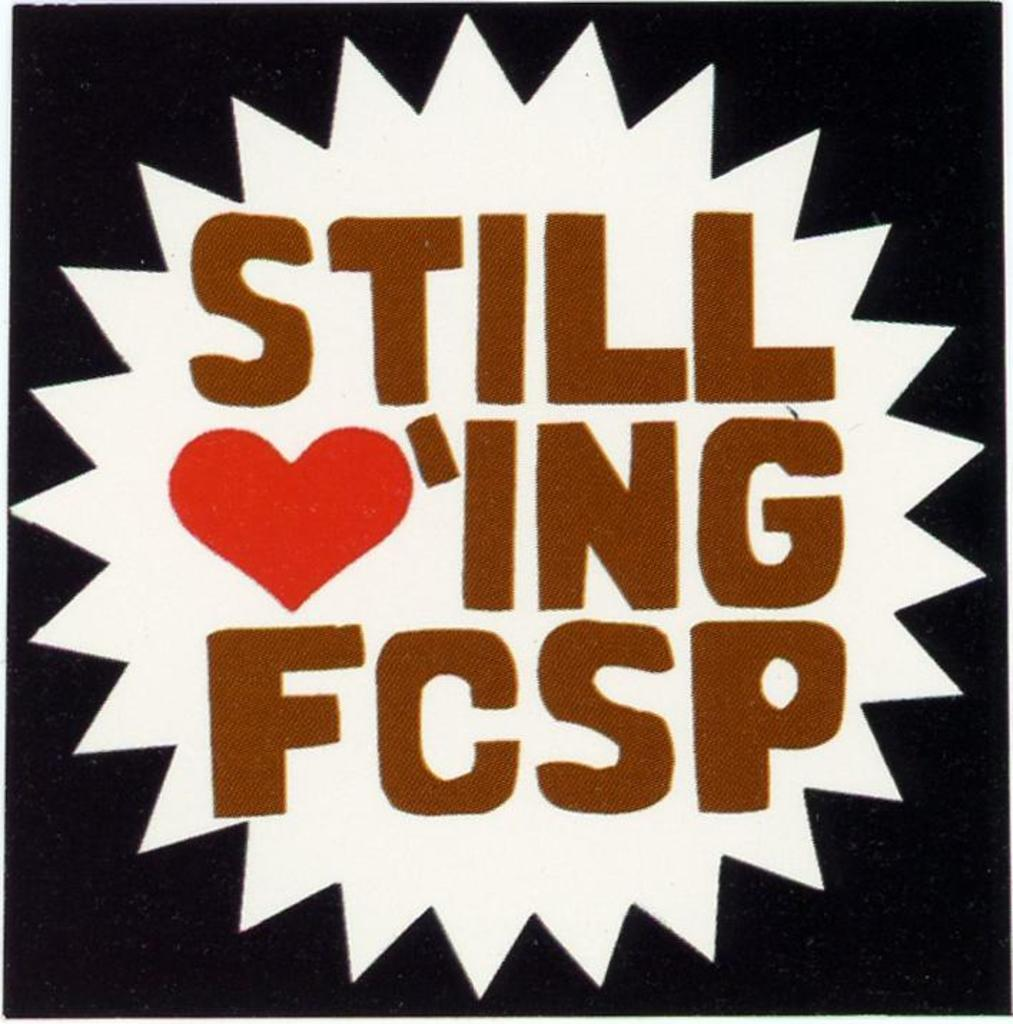<image>
Describe the image concisely. Icon saying in brown lettering that say Still loving FCSP. 